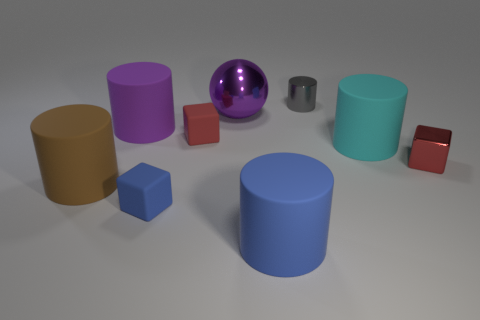Subtract all brown cylinders. How many cylinders are left? 4 Subtract all tiny cylinders. How many cylinders are left? 4 Subtract all yellow cylinders. Subtract all yellow balls. How many cylinders are left? 5 Add 1 large purple objects. How many objects exist? 10 Subtract all spheres. How many objects are left? 8 Subtract all tiny brown rubber blocks. Subtract all large purple rubber cylinders. How many objects are left? 8 Add 8 large purple metal spheres. How many large purple metal spheres are left? 9 Add 9 brown cylinders. How many brown cylinders exist? 10 Subtract 1 blue blocks. How many objects are left? 8 